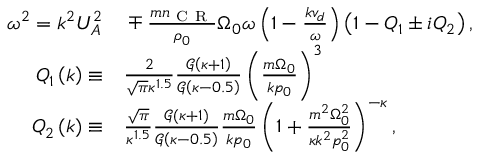<formula> <loc_0><loc_0><loc_500><loc_500>\begin{array} { r l } { \omega ^ { 2 } = k ^ { 2 } U _ { A } ^ { 2 } } & \mp \frac { m n _ { C R } } { \rho _ { 0 } } \Omega _ { 0 } \omega \left ( 1 - \frac { k v _ { d } } { \omega } \right ) \left ( 1 - Q _ { 1 } \pm i Q _ { 2 } \right ) , } \\ { Q _ { 1 } \left ( k \right ) \equiv } & \frac { 2 } { \sqrt { \pi } \kappa ^ { 1 . 5 } } \frac { \mathcal { G } \left ( \kappa + 1 \right ) } { \mathcal { G } \left ( \kappa - 0 . 5 \right ) } \left ( \frac { m \Omega _ { 0 } } { k p _ { 0 } } \right ) ^ { 3 } } \\ { Q _ { 2 } \left ( k \right ) \equiv } & \frac { \sqrt { \pi } } { \kappa ^ { 1 . 5 } } \frac { \mathcal { G } \left ( \kappa + 1 \right ) } { \mathcal { G } \left ( \kappa - 0 . 5 \right ) } \frac { m \Omega _ { 0 } } { k p _ { 0 } } \left ( 1 + \frac { m ^ { 2 } \Omega _ { 0 } ^ { 2 } } { \kappa k ^ { 2 } p _ { 0 } ^ { 2 } } \right ) ^ { - \kappa } , } \end{array}</formula> 